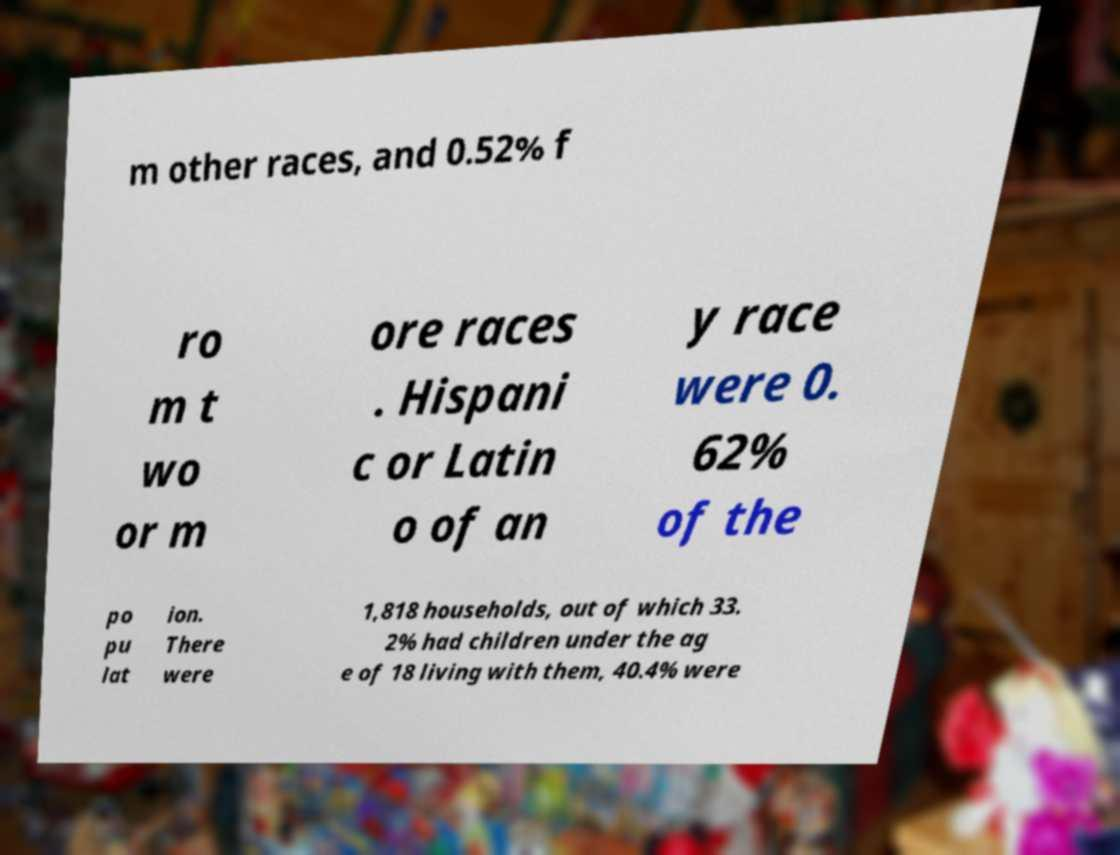There's text embedded in this image that I need extracted. Can you transcribe it verbatim? m other races, and 0.52% f ro m t wo or m ore races . Hispani c or Latin o of an y race were 0. 62% of the po pu lat ion. There were 1,818 households, out of which 33. 2% had children under the ag e of 18 living with them, 40.4% were 